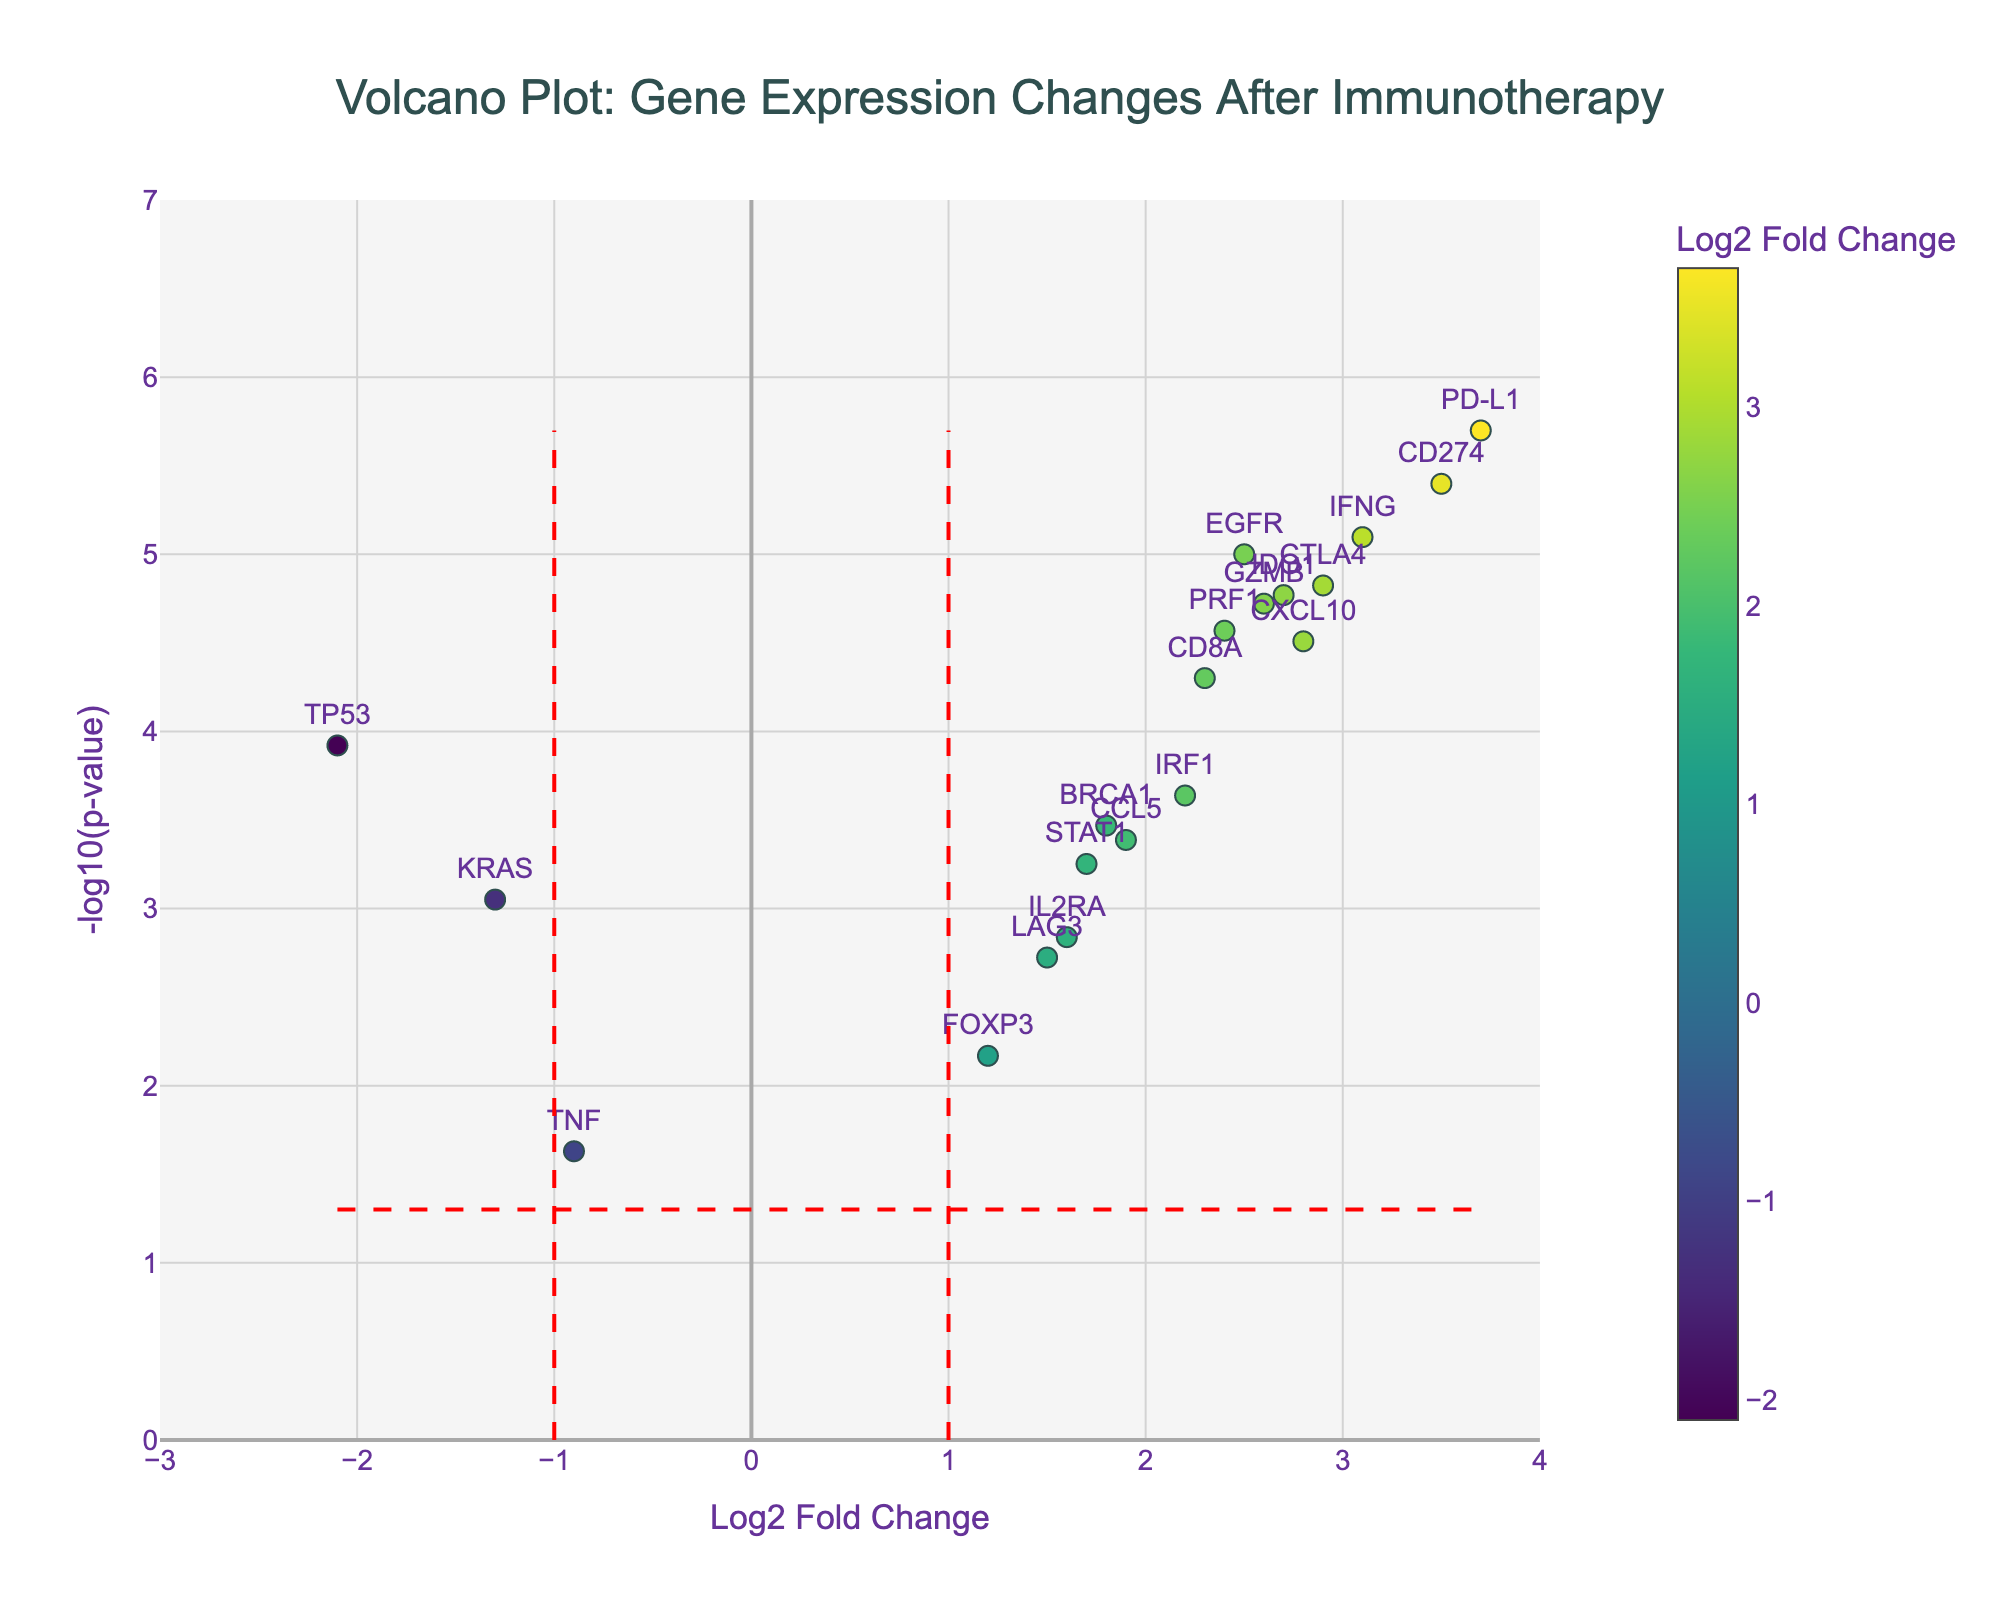Which gene has the highest positive log2 fold change? Look for the gene with the highest value on the x-axis (log2 fold change), which is to the rightmost side. In this case, it's PD-L1 with a log2 fold change of 3.7.
Answer: PD-L1 How many genes have a log2 fold change greater than 2? Count the number of genes with an x-axis value greater than 2. The genes are EGFR, PD-L1, CTLA4, CD8A, IFNG, CXCL10, GZMB, PRF1, CD274, and IDO1, making it 10 in total.
Answer: 10 What is the p-value threshold represented by the horizontal red dashed line? The horizontal red dashed line represents a p-value threshold of 0.05, which translates to -log10(0.05). Calculate -log10(0.05) ≈ 1.3.
Answer: 0.05 Which gene shows the most statistically significant change in expression (smallest p-value)? The most statistically significant gene is the one with the highest -log10(p-value) on the y-axis. PD-L1 has the highest -log10(p-value) value, which corresponds to the smallest actual p-value of 0.000002.
Answer: PD-L1 How many genes have p-values less than 0.001? Count the number of genes with a -log10(p-value) greater than -log10(0.001). By filtering, we find TP53, BRCA1, EGFR, PD-L1, CTLA4, CD8A, IFNG, STAT1, IRF1, CXCL10, GZMB, PRF1, CD274, and IDO1, totaling 14 genes.
Answer: 14 Which gene has the lowest negative log2 fold change? Look for the gene with the lowest value on the x-axis (log2 fold change), which is the leftmost side. In this case, it's TP53 with a log2 fold change of -2.1.
Answer: TP53 Compare the log2 fold changes of EGFR and BRCA1. Which one is greater, and by how much? EGFR has a log2 fold change of 2.5, and BRCA1 has 1.8. Subtract BRCA1's value from EGFR's value: 2.5 - 1.8 = 0.7. EGFR's value is greater by 0.7.
Answer: EGFR, by 0.7 What is the range of the log2 fold change values on the x-axis? Determine the minimum and maximum log2 fold change values from the x-axis. The minimum is -2.1 (TP53), and the maximum is 3.7 (PD-L1). The range is 3.7 - (-2.1) = 5.8.
Answer: 5.8 